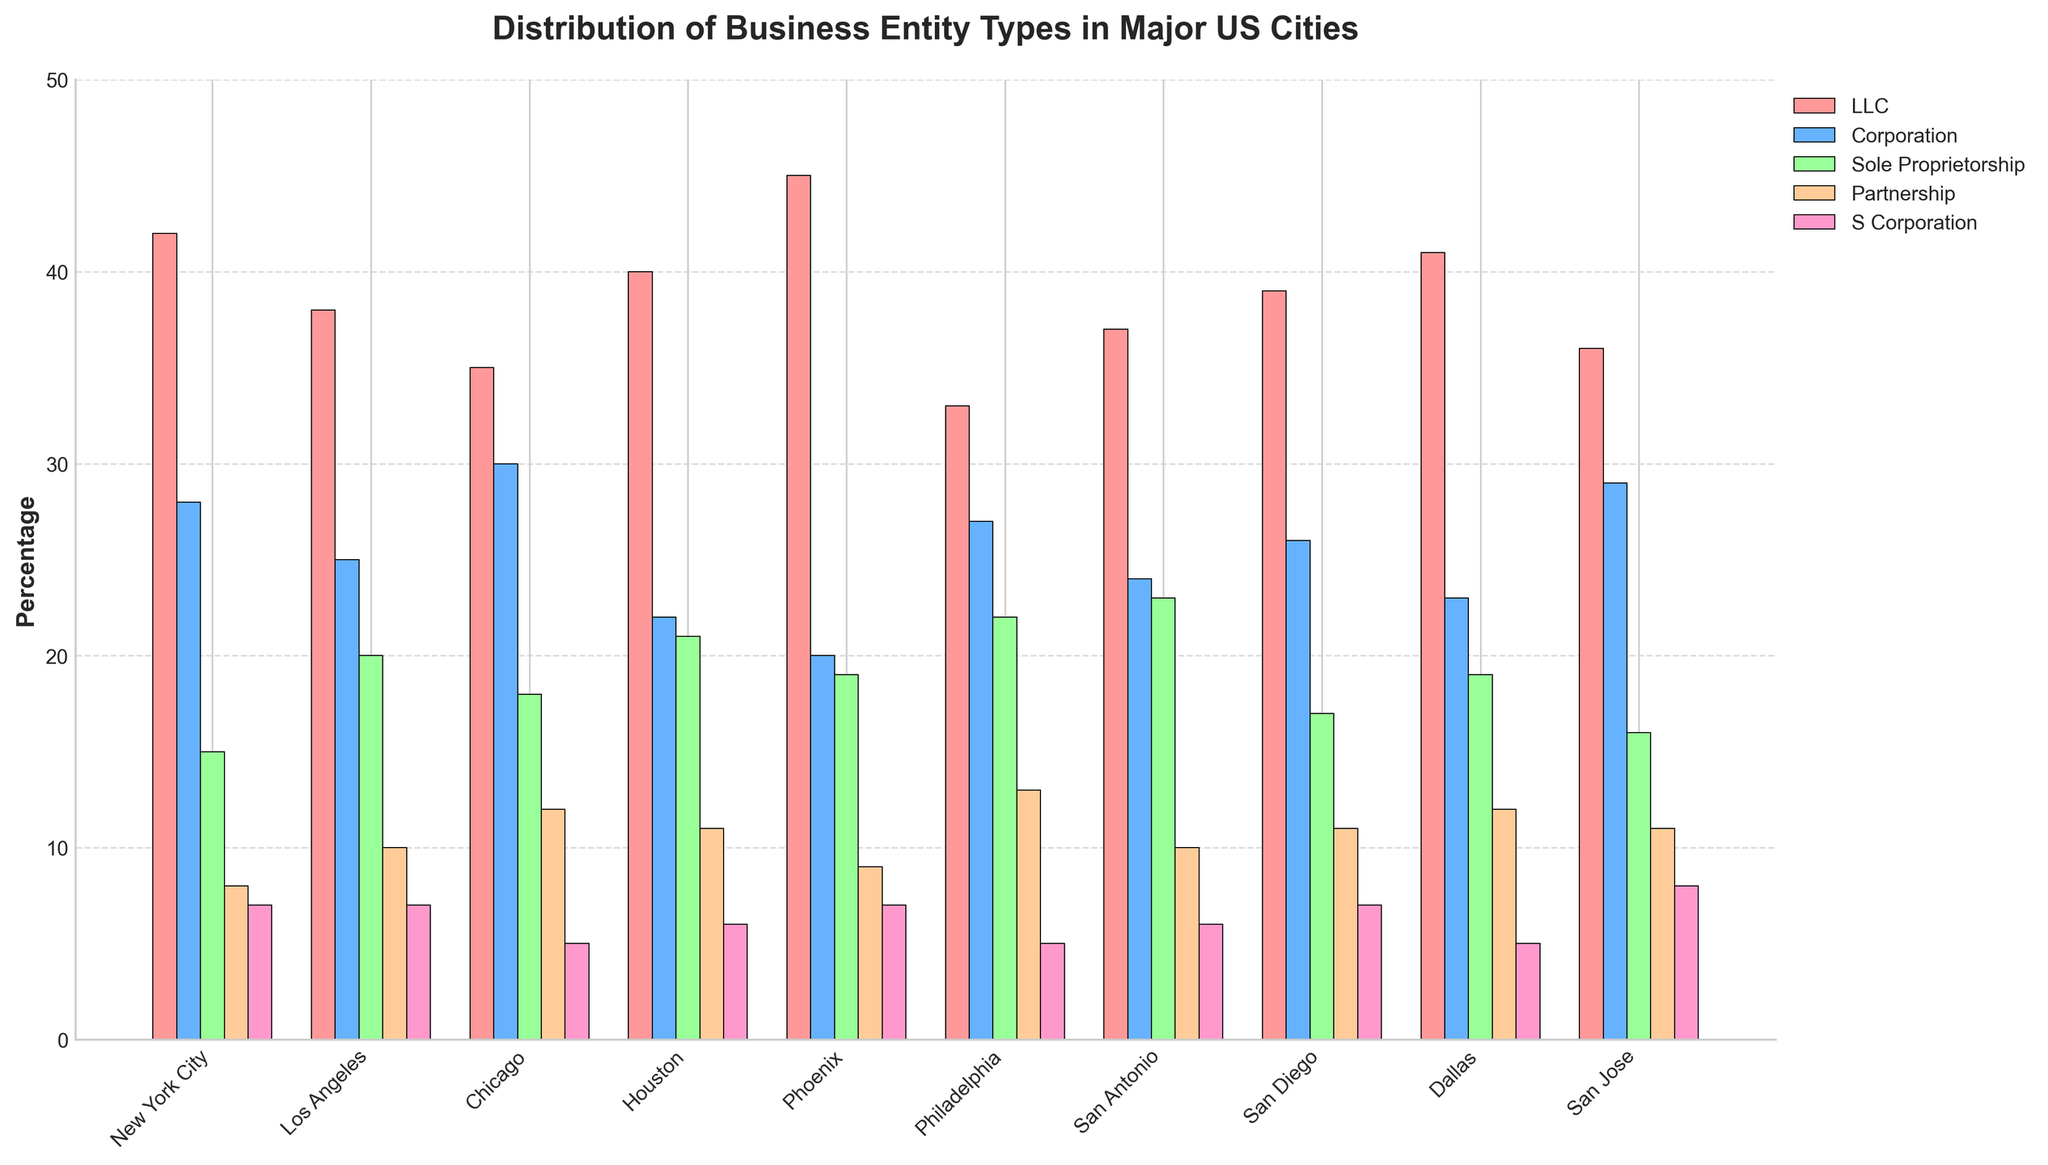What city has the largest number of LLCs registered? To find the city with the largest number of LLCs, we observe the bar for the LLC category across all cities. The tallest bar in this category indicates the city with the highest number of LLCs. Phoenix has the highest bar for LLCs.
Answer: Phoenix Which city has the fewest sole proprietorships registered? To identify the city with the fewest sole proprietorships, look for the shortest bar in the Sole Proprietorship category across all cities. New York City has the shortest bar for Sole Proprietorships.
Answer: New York City Which business entity type is the most common in Los Angeles? Check the heights of all the bars within Los Angeles for each entity type. The highest bar represents the most common entity type. The LLC category has the highest bar in Los Angeles.
Answer: LLC Compare the number of partnerships in Chicago and San Diego. Which city has more? Look at the bars for the Partnership category in both Chicago and San Diego. The bar in Chicago is slightly higher than the one in San Diego.
Answer: Chicago What is the sum of LLCs registered in New York City and Los Angeles? Add the number of LLCs in New York City (42) to the number of LLCs in Los Angeles (38). 42 + 38 = 80.
Answer: 80 What is the average number of sole proprietorships across all cities? Sum the number of sole proprietorships for all cities and divide by the number of cities. (15 + 20 + 18 + 21 + 19 + 22 + 23 + 17 + 19 + 16) / 10 = 190 / 10 = 19.
Answer: 19 In San Antonio, which business entity type has the second highest registration? For San Antonio, check the bars and rank them by height. The second highest bar is in the Sole Proprietorship category.
Answer: Sole Proprietorship Do more corporations register in Philadelphia or Dallas? Compare the height of the Corporation bars for Philadelphia and Dallas. Philadelphia's Corporation bar is higher than Dallas's.
Answer: Philadelphia Which business entity type is least common in San Jose? For San Jose, look for the shortest bar among all the business entity types. The shortest bar belongs to the Partnership category.
Answer: Partnership What is the total number of S Corporations registered in Houston, Phoenix, and San Diego combined? Add the number of S Corporations in Houston (6), Phoenix (7), and San Diego (7). 6 + 7 + 7 = 20.
Answer: 20 